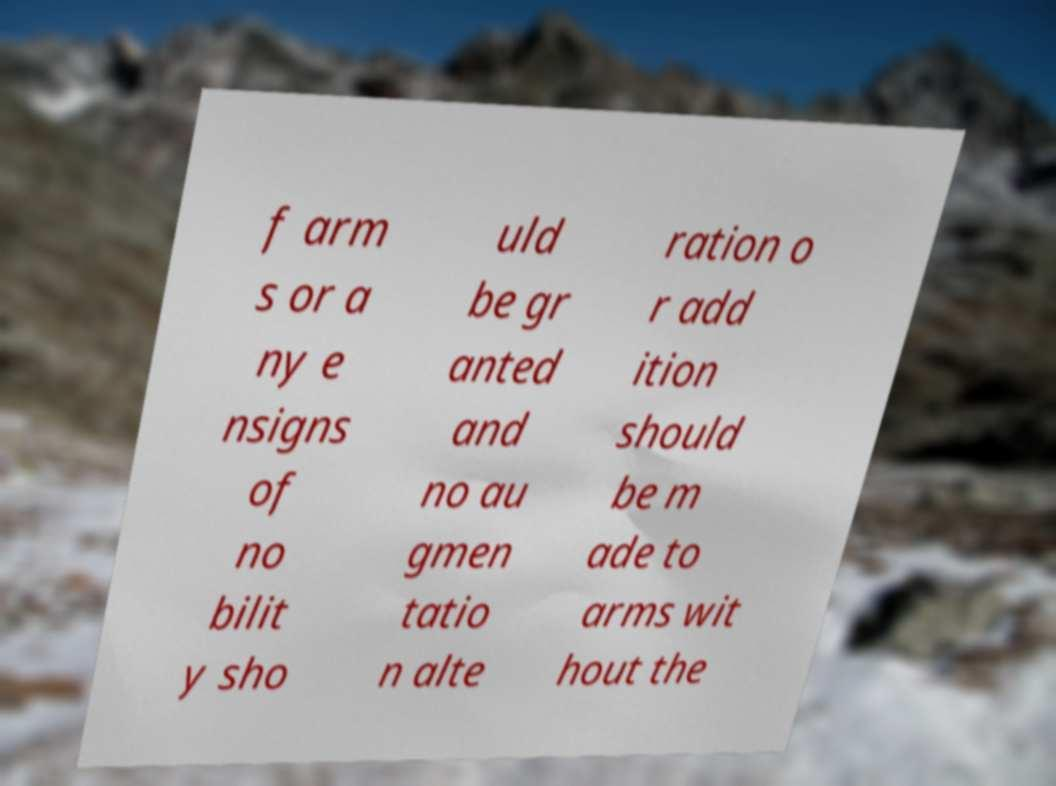Could you assist in decoding the text presented in this image and type it out clearly? f arm s or a ny e nsigns of no bilit y sho uld be gr anted and no au gmen tatio n alte ration o r add ition should be m ade to arms wit hout the 